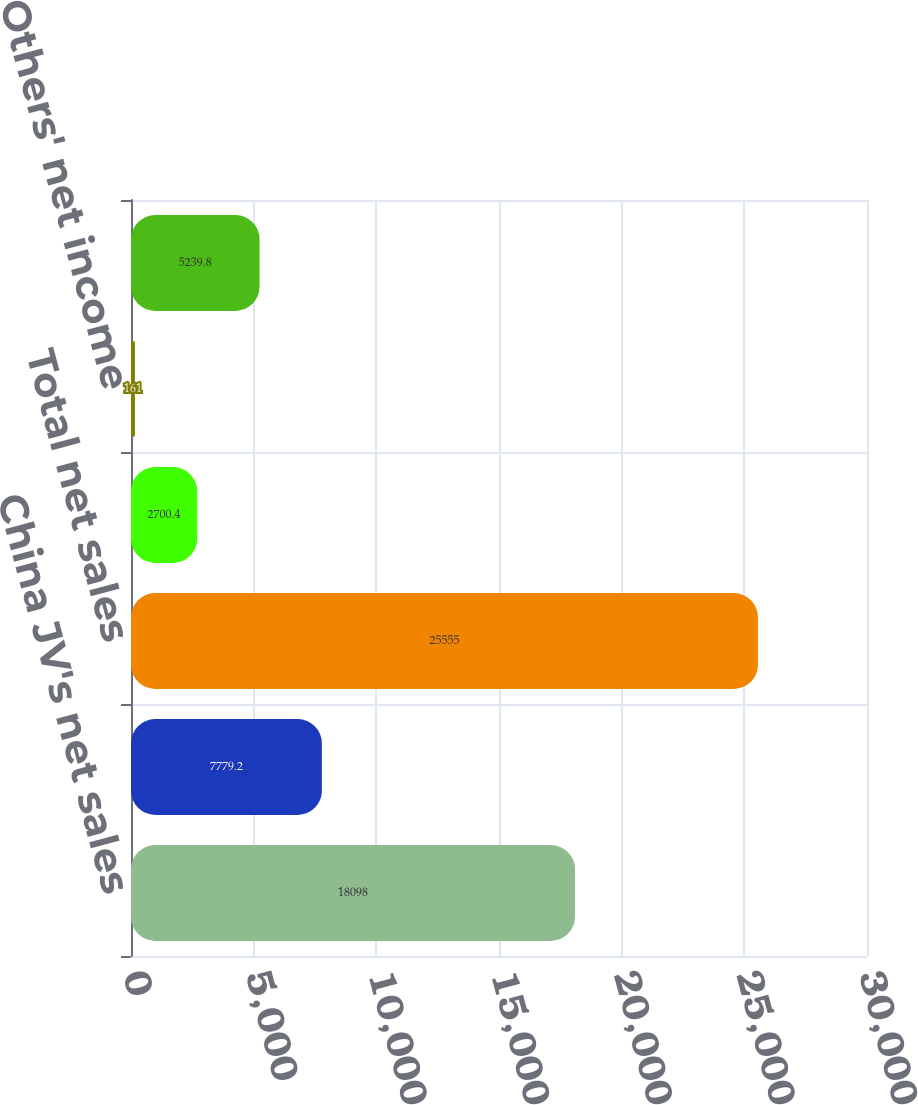Convert chart. <chart><loc_0><loc_0><loc_500><loc_500><bar_chart><fcel>China JV's net sales<fcel>Others' net sales<fcel>Total net sales<fcel>China JV's net income<fcel>Others' net income<fcel>Total net income<nl><fcel>18098<fcel>7779.2<fcel>25555<fcel>2700.4<fcel>161<fcel>5239.8<nl></chart> 